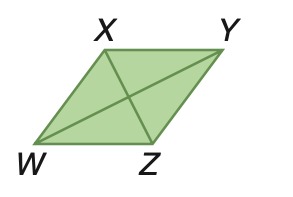Answer the mathemtical geometry problem and directly provide the correct option letter.
Question: Rhombus W X Y Z has an area of 100 square meters. Find W Y if X Z = 10 meters.
Choices: A: 5 B: 10 C: 20 D: 40 C 